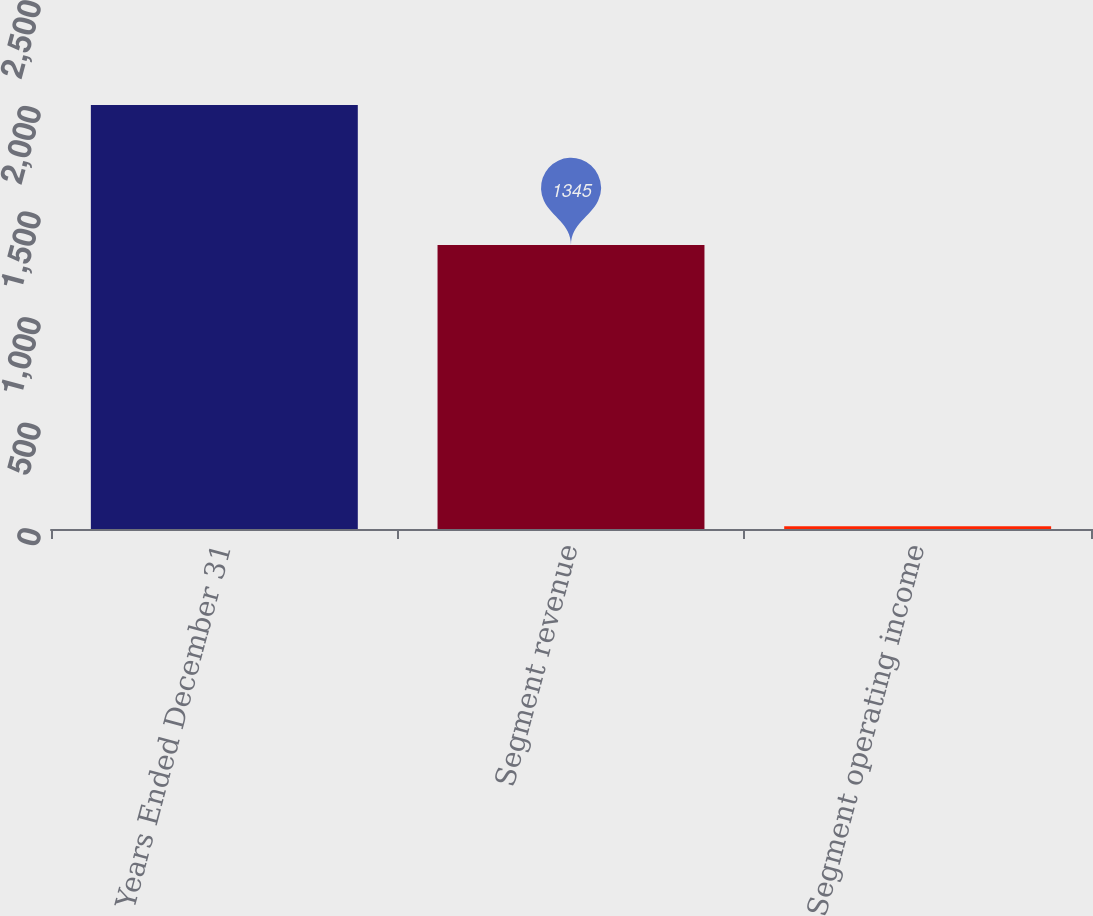Convert chart to OTSL. <chart><loc_0><loc_0><loc_500><loc_500><bar_chart><fcel>Years Ended December 31<fcel>Segment revenue<fcel>Segment operating income<nl><fcel>2007<fcel>1345<fcel>13.4<nl></chart> 